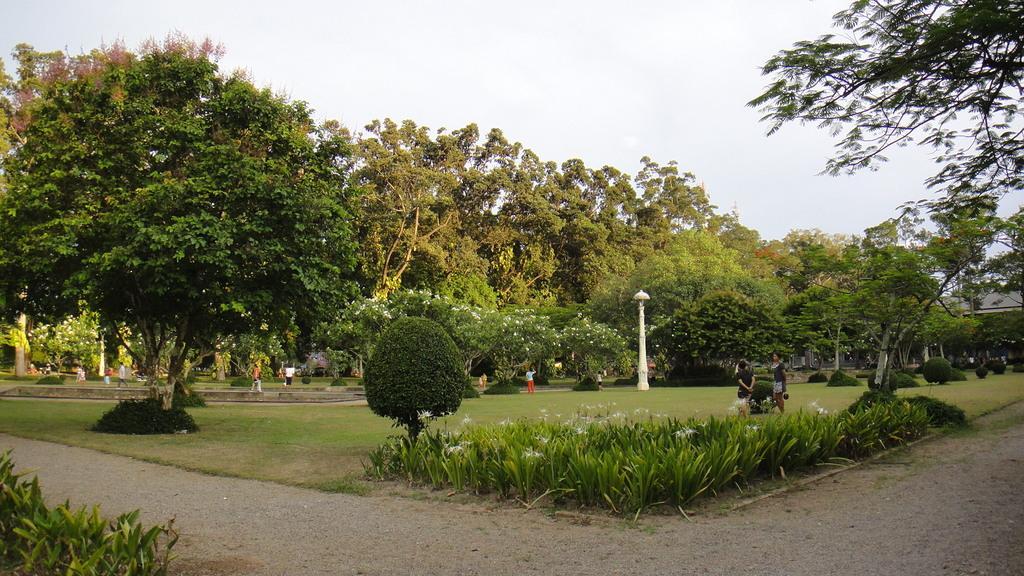Please provide a concise description of this image. In the picture I can see so many trees, flowers to the plants, some people are on the grass and beside we can see the road. 